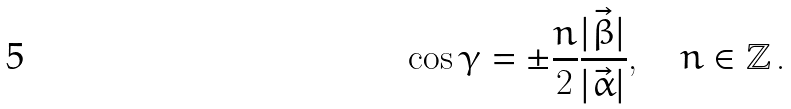Convert formula to latex. <formula><loc_0><loc_0><loc_500><loc_500>\cos \gamma = \pm \frac { n } { 2 } \frac { | \vec { \beta } | } { | \vec { \alpha } | } , \quad n \in \mathbb { Z } \, .</formula> 